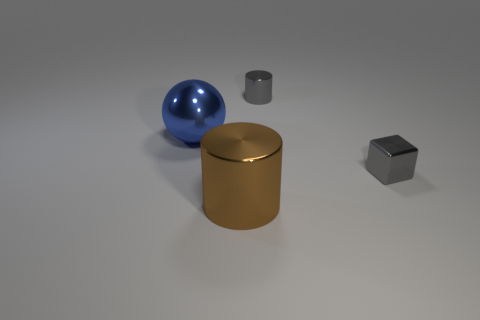How many rubber things are either small red spheres or big brown cylinders?
Your response must be concise. 0. The cylinder behind the blue metal ball is what color?
Keep it short and to the point. Gray. What shape is the gray thing that is the same size as the gray cube?
Offer a very short reply. Cylinder. Does the metallic block have the same color as the big object in front of the big blue metal sphere?
Your answer should be very brief. No. What number of things are either small metallic objects behind the blue sphere or tiny gray shiny objects behind the cube?
Offer a very short reply. 1. There is a gray object that is the same size as the gray shiny cylinder; what is it made of?
Ensure brevity in your answer.  Metal. What number of other things are there of the same material as the small block
Your answer should be very brief. 3. There is a large metallic object that is to the left of the big brown metallic object; is its shape the same as the small gray metallic object on the left side of the cube?
Keep it short and to the point. No. There is a metallic thing right of the shiny object behind the metallic object on the left side of the brown metal thing; what is its color?
Make the answer very short. Gray. How many other things are the same color as the metallic block?
Make the answer very short. 1. 